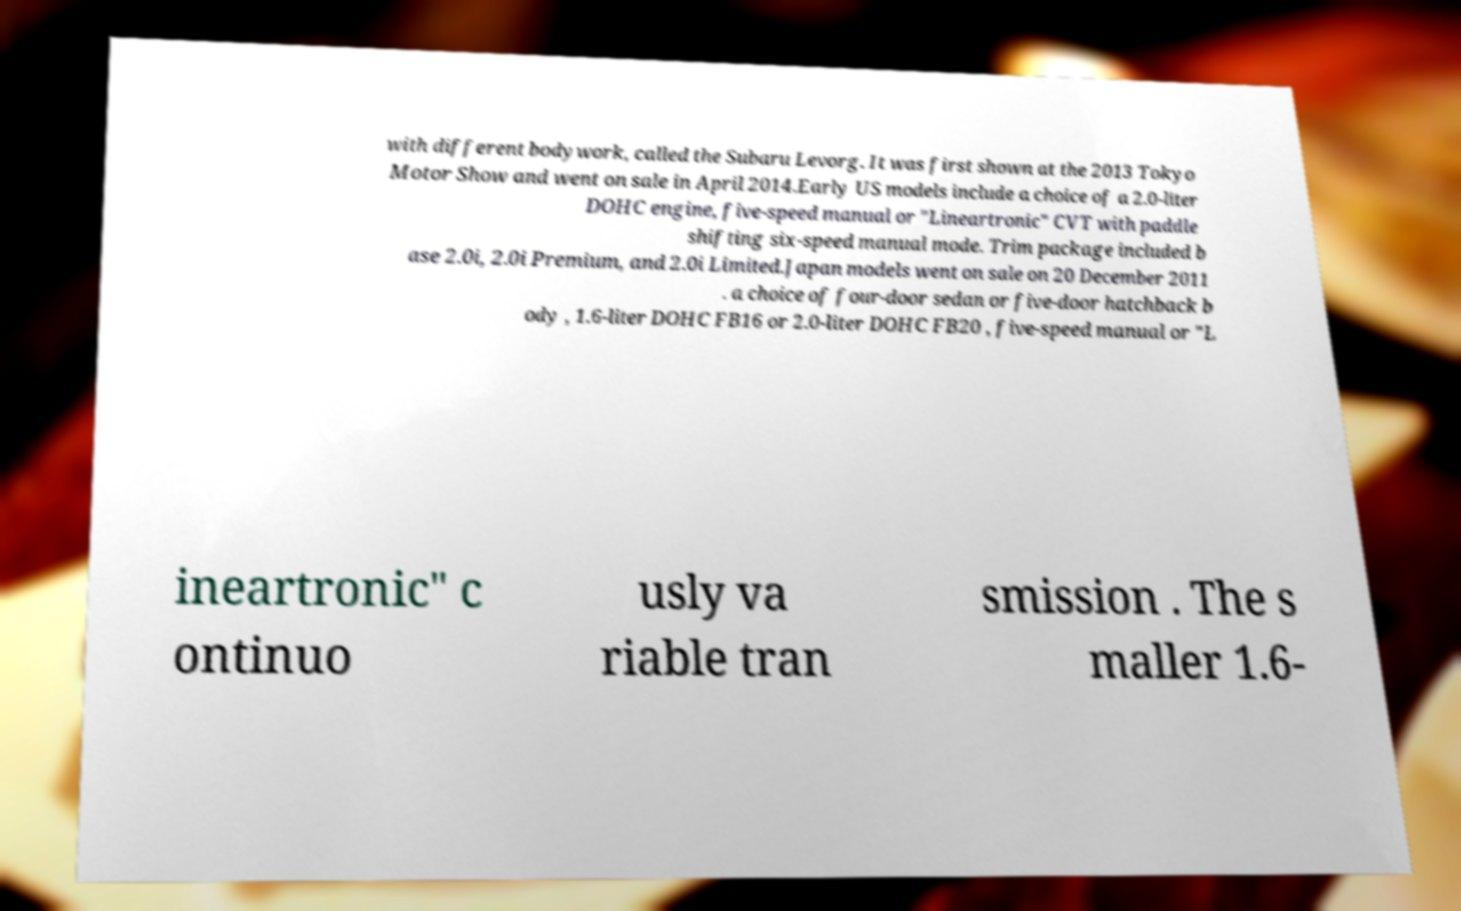I need the written content from this picture converted into text. Can you do that? with different bodywork, called the Subaru Levorg. It was first shown at the 2013 Tokyo Motor Show and went on sale in April 2014.Early US models include a choice of a 2.0-liter DOHC engine, five-speed manual or "Lineartronic" CVT with paddle shifting six-speed manual mode. Trim package included b ase 2.0i, 2.0i Premium, and 2.0i Limited.Japan models went on sale on 20 December 2011 . a choice of four-door sedan or five-door hatchback b ody , 1.6-liter DOHC FB16 or 2.0-liter DOHC FB20 , five-speed manual or "L ineartronic" c ontinuo usly va riable tran smission . The s maller 1.6- 